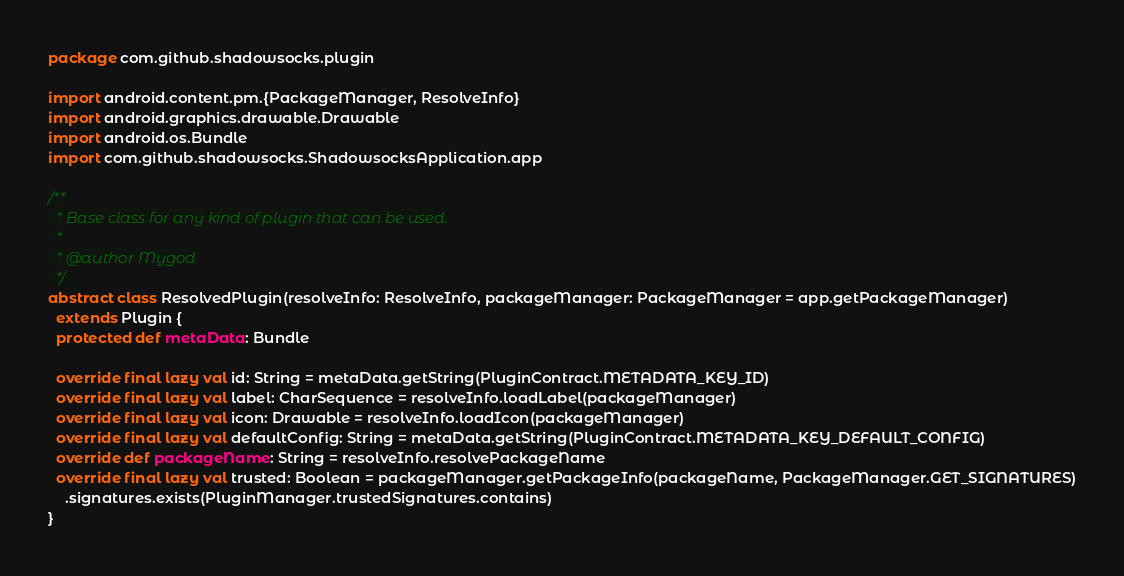Convert code to text. <code><loc_0><loc_0><loc_500><loc_500><_Scala_>package com.github.shadowsocks.plugin

import android.content.pm.{PackageManager, ResolveInfo}
import android.graphics.drawable.Drawable
import android.os.Bundle
import com.github.shadowsocks.ShadowsocksApplication.app

/**
  * Base class for any kind of plugin that can be used.
  *
  * @author Mygod
  */
abstract class ResolvedPlugin(resolveInfo: ResolveInfo, packageManager: PackageManager = app.getPackageManager)
  extends Plugin {
  protected def metaData: Bundle

  override final lazy val id: String = metaData.getString(PluginContract.METADATA_KEY_ID)
  override final lazy val label: CharSequence = resolveInfo.loadLabel(packageManager)
  override final lazy val icon: Drawable = resolveInfo.loadIcon(packageManager)
  override final lazy val defaultConfig: String = metaData.getString(PluginContract.METADATA_KEY_DEFAULT_CONFIG)
  override def packageName: String = resolveInfo.resolvePackageName
  override final lazy val trusted: Boolean = packageManager.getPackageInfo(packageName, PackageManager.GET_SIGNATURES)
    .signatures.exists(PluginManager.trustedSignatures.contains)
}
</code> 